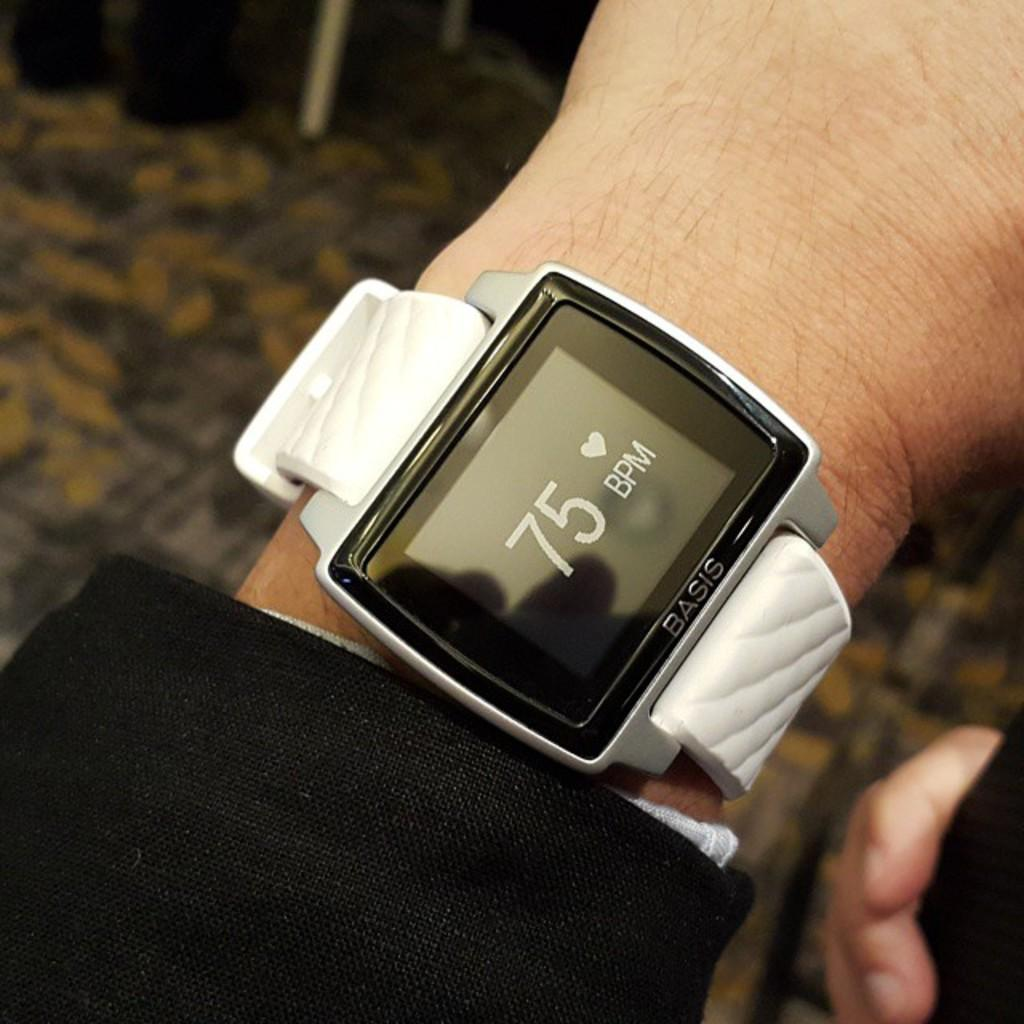Provide a one-sentence caption for the provided image. a fitbit with a white band that has 75 BPM on the front. 